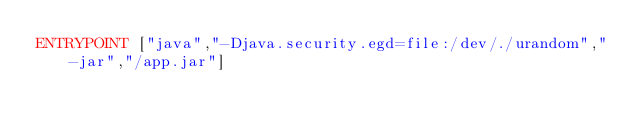<code> <loc_0><loc_0><loc_500><loc_500><_Dockerfile_>ENTRYPOINT ["java","-Djava.security.egd=file:/dev/./urandom","-jar","/app.jar"]
</code> 